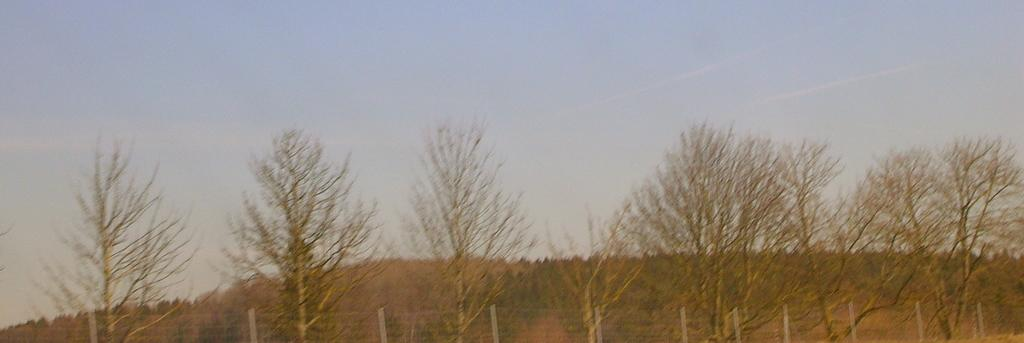Where was the image taken? The image was taken outdoors. What can be seen at the top of the image? The sky is visible at the top of the image. What type of vegetation is present at the bottom of the image? There are many trees and plants at the bottom of the image. What type of barrier is present in the image? There is a fencing in the image. What type of collar is visible on the tree in the image? There is no collar present on any tree in the image. What scientific theory can be observed in the image? There is no scientific theory depicted in the image; it features an outdoor scene with trees, plants, and a sky. 